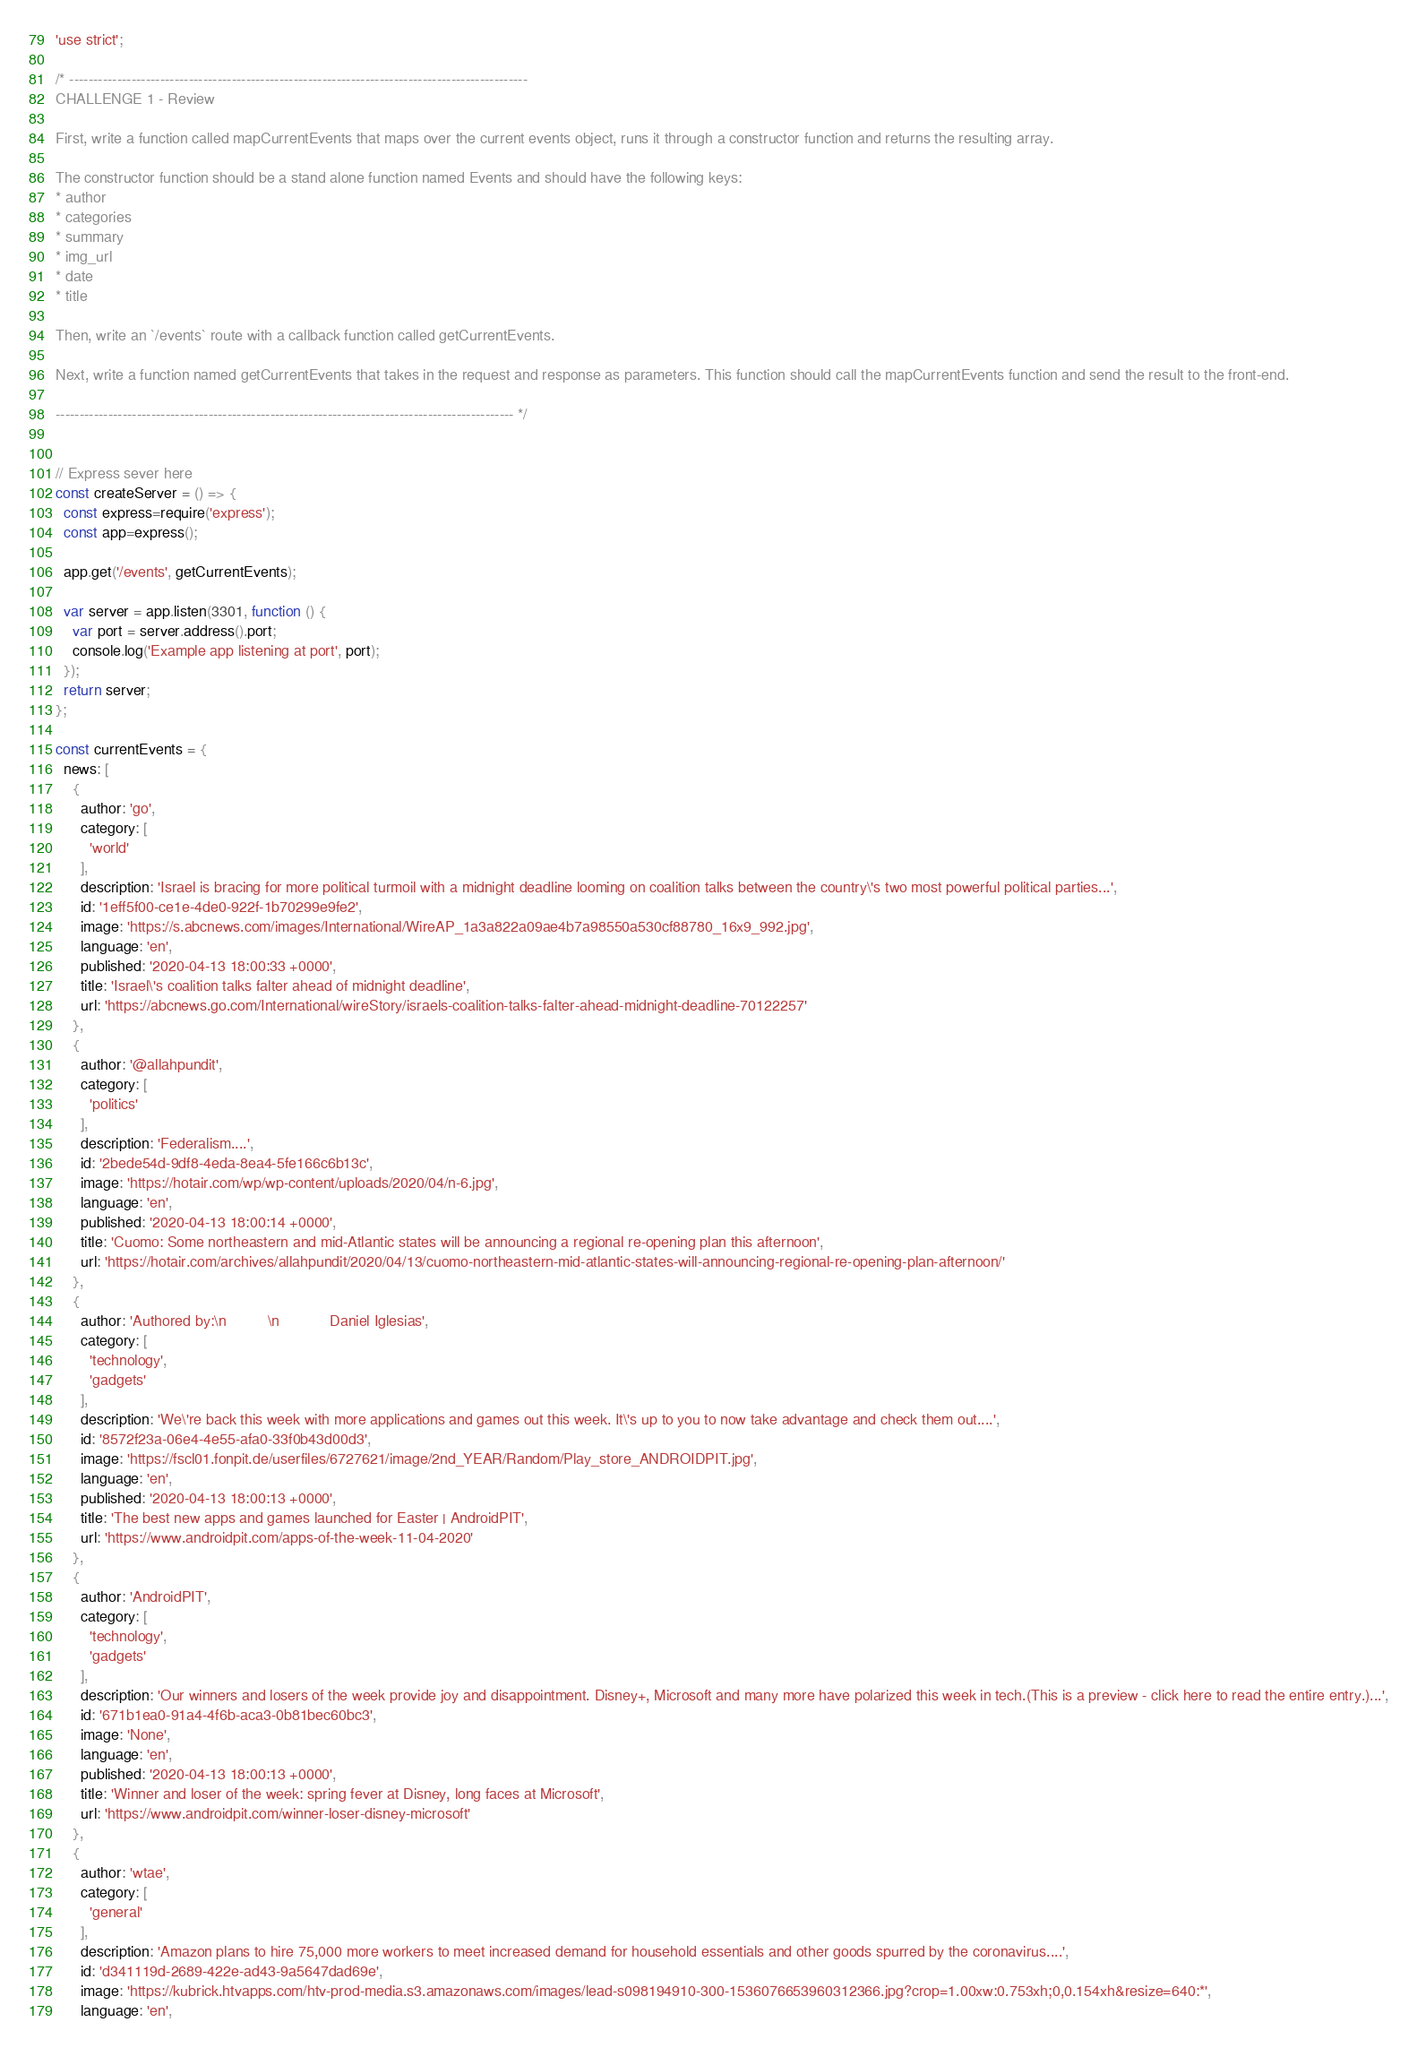<code> <loc_0><loc_0><loc_500><loc_500><_JavaScript_>'use strict';

/* ------------------------------------------------------------------------------------------------
CHALLENGE 1 - Review

First, write a function called mapCurrentEvents that maps over the current events object, runs it through a constructor function and returns the resulting array.

The constructor function should be a stand alone function named Events and should have the following keys:
* author
* categories
* summary
* img_url
* date
* title

Then, write an `/events` route with a callback function called getCurrentEvents.

Next, write a function named getCurrentEvents that takes in the request and response as parameters. This function should call the mapCurrentEvents function and send the result to the front-end.

------------------------------------------------------------------------------------------------ */


// Express sever here
const createServer = () => {
  const express=require('express');
  const app=express();

  app.get('/events', getCurrentEvents);

  var server = app.listen(3301, function () {
    var port = server.address().port;
    console.log('Example app listening at port', port);
  });
  return server;
};

const currentEvents = {
  news: [
    {
      author: 'go',
      category: [
        'world'
      ],
      description: 'Israel is bracing for more political turmoil with a midnight deadline looming on coalition talks between the country\'s two most powerful political parties...',
      id: '1eff5f00-ce1e-4de0-922f-1b70299e9fe2',
      image: 'https://s.abcnews.com/images/International/WireAP_1a3a822a09ae4b7a98550a530cf88780_16x9_992.jpg',
      language: 'en',
      published: '2020-04-13 18:00:33 +0000',
      title: 'Israel\'s coalition talks falter ahead of midnight deadline',
      url: 'https://abcnews.go.com/International/wireStory/israels-coalition-talks-falter-ahead-midnight-deadline-70122257'
    },
    {
      author: '@allahpundit',
      category: [
        'politics'
      ],
      description: 'Federalism....',
      id: '2bede54d-9df8-4eda-8ea4-5fe166c6b13c',
      image: 'https://hotair.com/wp/wp-content/uploads/2020/04/n-6.jpg',
      language: 'en',
      published: '2020-04-13 18:00:14 +0000',
      title: 'Cuomo: Some northeastern and mid-Atlantic states will be announcing a regional re-opening plan this afternoon',
      url: 'https://hotair.com/archives/allahpundit/2020/04/13/cuomo-northeastern-mid-atlantic-states-will-announcing-regional-re-opening-plan-afternoon/'
    },
    {
      author: 'Authored by:\n          \n            Daniel Iglesias',
      category: [
        'technology',
        'gadgets'
      ],
      description: 'We\'re back this week with more applications and games out this week. It\'s up to you to now take advantage and check them out....',
      id: '8572f23a-06e4-4e55-afa0-33f0b43d00d3',
      image: 'https://fscl01.fonpit.de/userfiles/6727621/image/2nd_YEAR/Random/Play_store_ANDROIDPIT.jpg',
      language: 'en',
      published: '2020-04-13 18:00:13 +0000',
      title: 'The best new apps and games launched for Easter | AndroidPIT',
      url: 'https://www.androidpit.com/apps-of-the-week-11-04-2020'
    },
    {
      author: 'AndroidPIT',
      category: [
        'technology',
        'gadgets'
      ],
      description: 'Our winners and losers of the week provide joy and disappointment. Disney+, Microsoft and many more have polarized this week in tech.(This is a preview - click here to read the entire entry.)...',
      id: '671b1ea0-91a4-4f6b-aca3-0b81bec60bc3',
      image: 'None',
      language: 'en',
      published: '2020-04-13 18:00:13 +0000',
      title: 'Winner and loser of the week: spring fever at Disney, long faces at Microsoft',
      url: 'https://www.androidpit.com/winner-loser-disney-microsoft'
    },
    {
      author: 'wtae',
      category: [
        'general'
      ],
      description: 'Amazon plans to hire 75,000 more workers to meet increased demand for household essentials and other goods spurred by the coronavirus....',
      id: 'd341119d-2689-422e-ad43-9a5647dad69e',
      image: 'https://kubrick.htvapps.com/htv-prod-media.s3.amazonaws.com/images/lead-s098194910-300-1536076653960312366.jpg?crop=1.00xw:0.753xh;0,0.154xh&resize=640:*',
      language: 'en',</code> 